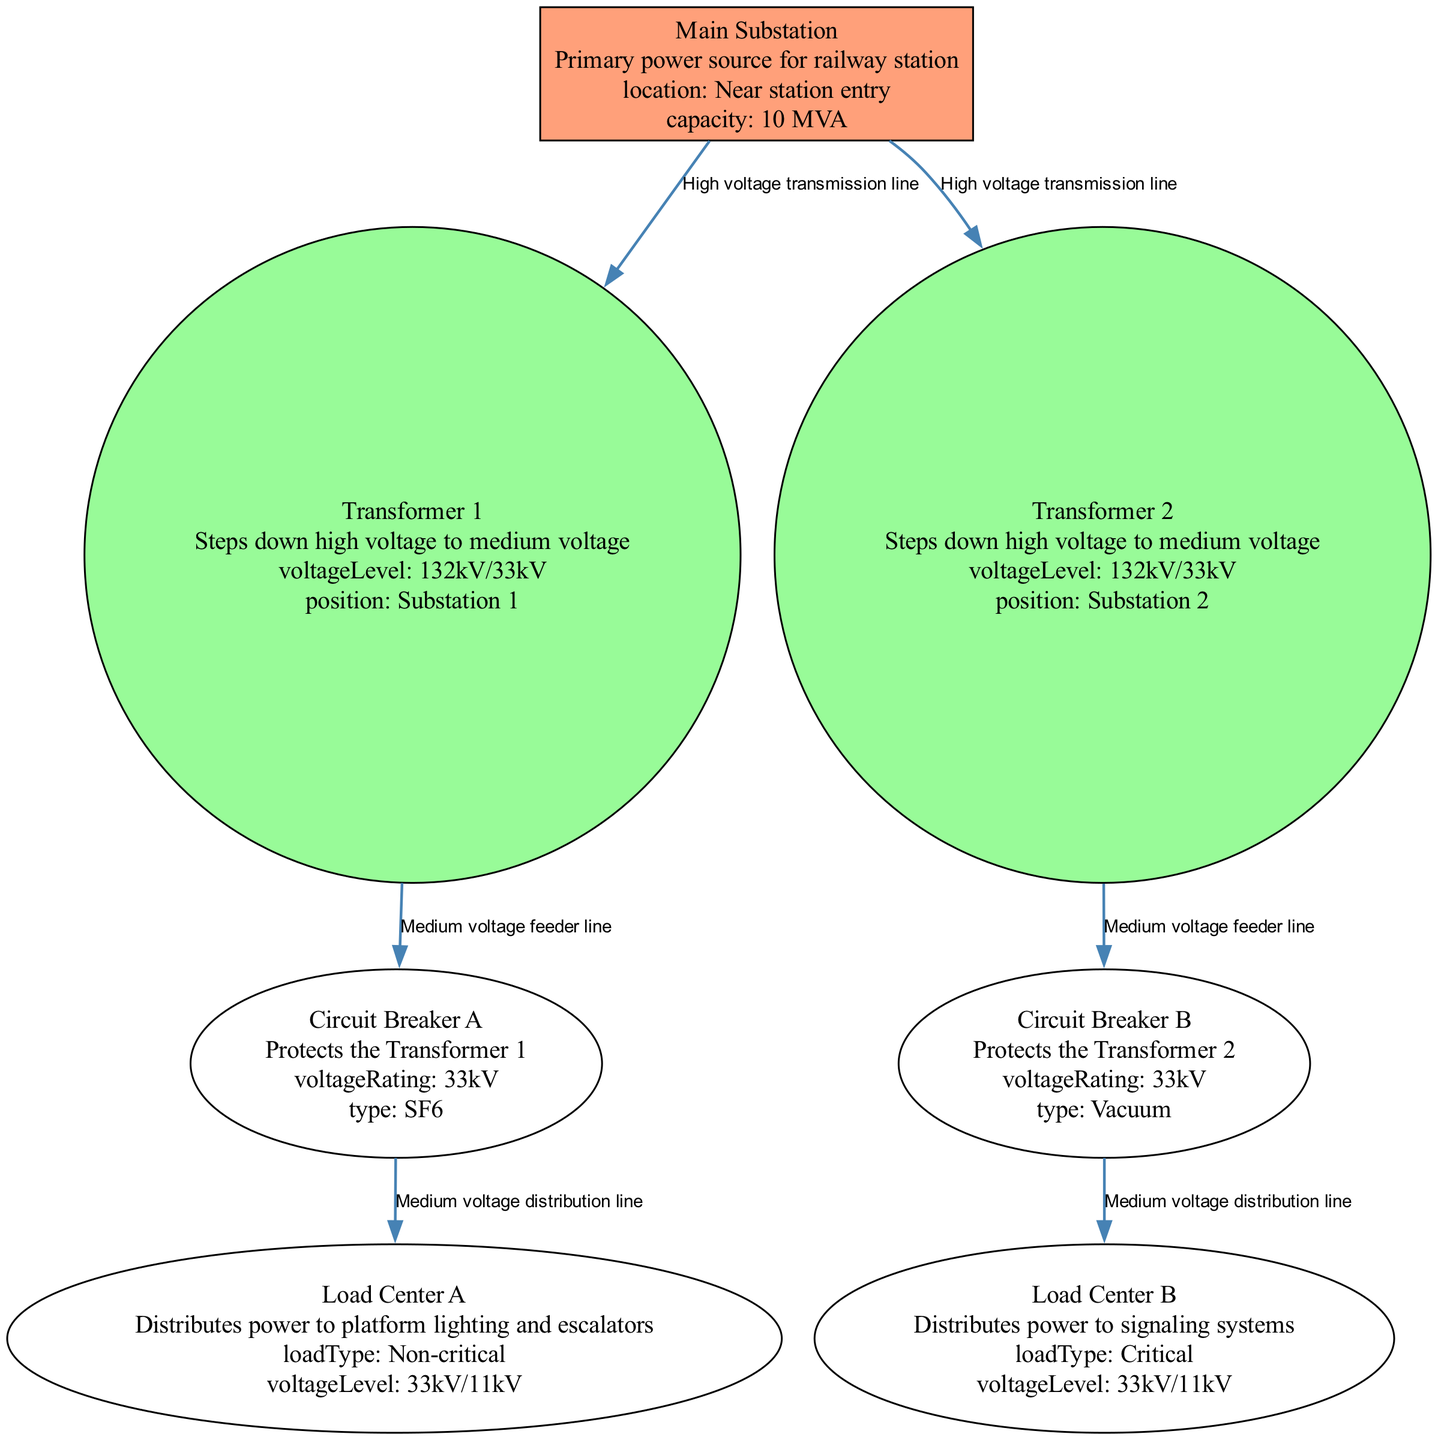What is the capacity of the Main Substation? The diagram indicates that the Main Substation has a capacity attribute of "10 MVA". This information is directly provided in the description of the Main Substation node.
Answer: 10 MVA Where is Transformer 1 positioned? Looking at Transformer 1's attributes in the diagram, its position is specified as "Substation 1". This location is indicated in the attributes section of the Transformer 1 node.
Answer: Substation 1 How many circuit breakers are present in the diagram? By counting the nodes labeled as circuit breakers, we can see that there are two: Circuit Breaker A and Circuit Breaker B. This count is derived from the node types specified in the diagram.
Answer: 2 What type of load is connected to Load Center B? Load Center B has a load type described as "Critical" in its attributes. This attribute directly states the nature of the load associated with Load Center B.
Answer: Critical What is the voltage rating of Circuit Breaker A? The voltage rating for Circuit Breaker A is specified as "33kV". This information can be found in the attributes of the Circuit Breaker A node in the diagram.
Answer: 33kV Which transformer is connected to Load Center A? Load Center A is connected through the edge labeled as "Medium voltage distribution line" from Circuit Breaker A, which is in turn connected to Transformer 1. Thus, Load Center A is connected to Transformer 1 indirectly.
Answer: Transformer 1 What is the type of Transformer 2? The diagram indicates that both Transformer 1 and Transformer 2 serve the same function of stepping down high voltage to medium voltage, and since they are of the same type, we can conclude Transformer 2 is a transformer of similar specifications. However, specific transformer types (like oil-filled, dry-type) are not defined in this data; thus, we refer only to the fact that it is a transformer.
Answer: Transformer What kind of power systems do Load Center A and Load Center B supply? Load Center A supplies "Non-critical" systems such as platform lighting and escalators, while Load Center B supplies "Critical" systems specifically for signaling. This distinction is noted in their respective attributes and highlights their different roles.
Answer: Non-critical, Critical What is the type of Circuit Breaker B? The type of Circuit Breaker B is described as "Vacuum" in its attributes section. By looking at the details provided for Circuit Breaker B, we can easily identify this type.
Answer: Vacuum 